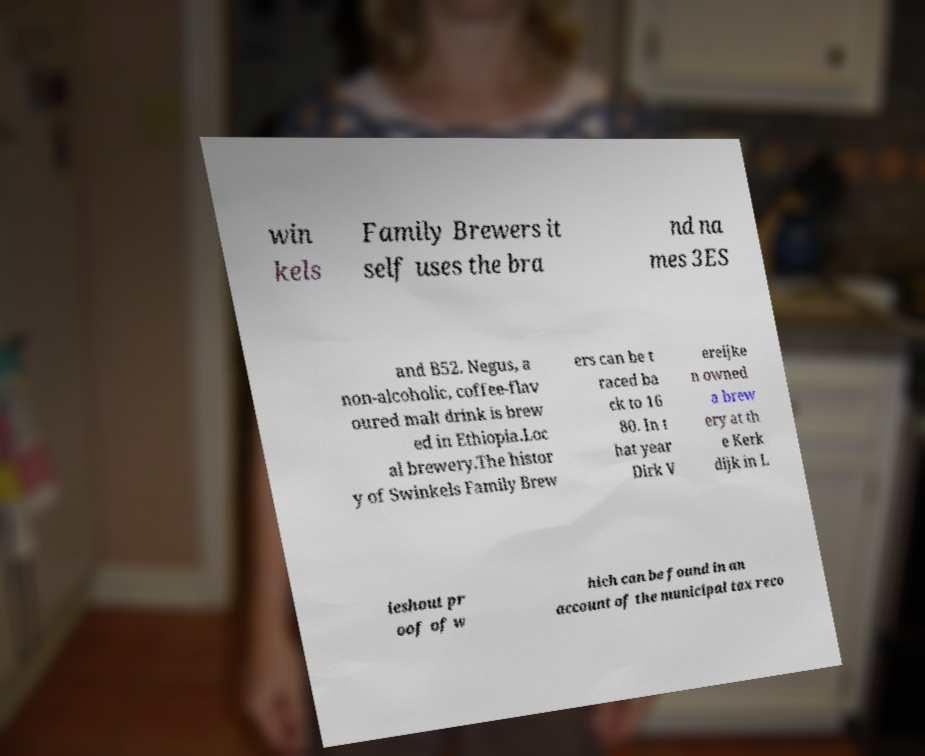I need the written content from this picture converted into text. Can you do that? win kels Family Brewers it self uses the bra nd na mes 3ES and B52. Negus, a non-alcoholic, coffee-flav oured malt drink is brew ed in Ethiopia.Loc al brewery.The histor y of Swinkels Family Brew ers can be t raced ba ck to 16 80. In t hat year Dirk V ereijke n owned a brew ery at th e Kerk dijk in L ieshout pr oof of w hich can be found in an account of the municipal tax reco 